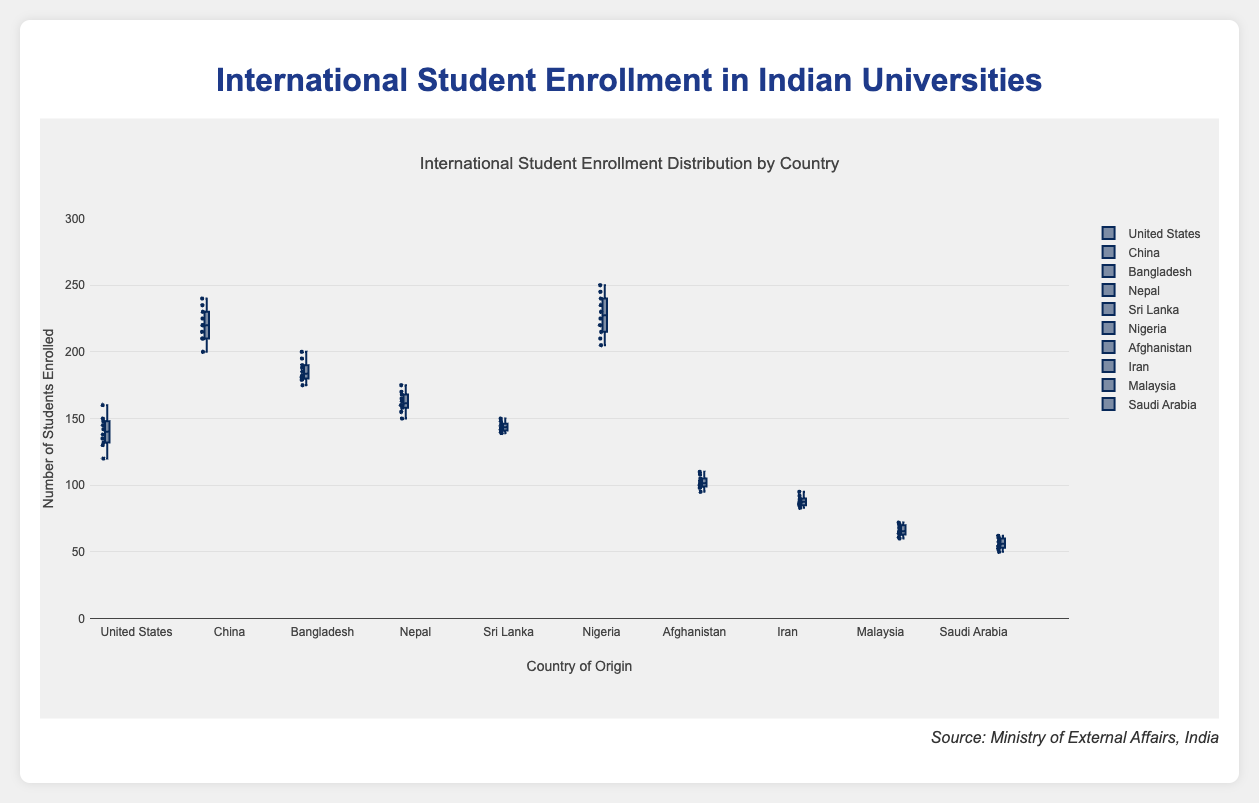What is the title of the box plot? The title is displayed at the top center of the plot. It provides the main heading of the visualization, summarizing what is being depicted.
Answer: International Student Enrollment Distribution by Country Which country has the highest median number of enrollments? To determine the country with the highest median number of enrollments, examine the median line (middle line) in each box. The highest median value line corresponds to the highest number of enrollments.
Answer: Nigeria What is the range of the y-axis? The range of the y-axis can be found by looking at the lowest and highest values displayed along the y-axis.
Answer: 0 to 300 Which country has the least variability in student enrollments? The variability can be assessed by the length of the box. The country with the smallest box has the least variability in enrollments.
Answer: Iran How does the median enrollment for students from the United States compare to that for students from Afghanistan? Compare the median lines (middle lines) of the boxes for both countries. The position of these lines will indicate if one is higher or lower than the other.
Answer: The median enrollment for the United States is higher than Afghanistan What is the interquartile range (IQR) for student enrollments from China? The IQR is the range between the first quartile (Q1) and the third quartile (Q3). It is represented by the length of the box itself. To find it, note the value at the lower edge (Q1) and the value at the upper edge (Q3) of China's box.
Answer: 25 (250 - 225) Which country has the highest maximum enrollment, as shown by the whiskers? The maximum enrollment can be found by identifying the highest point (whisker) extending from any of the boxes.
Answer: Nigeria What can be inferred about the student enrollments from Saudi Arabia compared to Malaysia? To infer this, compare the sizes, medians, and ranges of the boxes for both countries. Notice the median lines and the spread of the data points.
Answer: Saudi Arabia has higher enrollments and a greater range than Malaysia How would you describe the overall distribution of student enrollments from Bangladesh? The distribution can be described by looking at the box plot characteristics such as the median, IQR, range, and outliers.
Answer: The enrollments have a moderate spread with no significant outliers and a median around 185 Which countries have close median enrollments around 140-150? Look for countries whose median lines (middle lines in the boxes) fall within the 140-150 range.
Answer: United States and Sri Lanka 